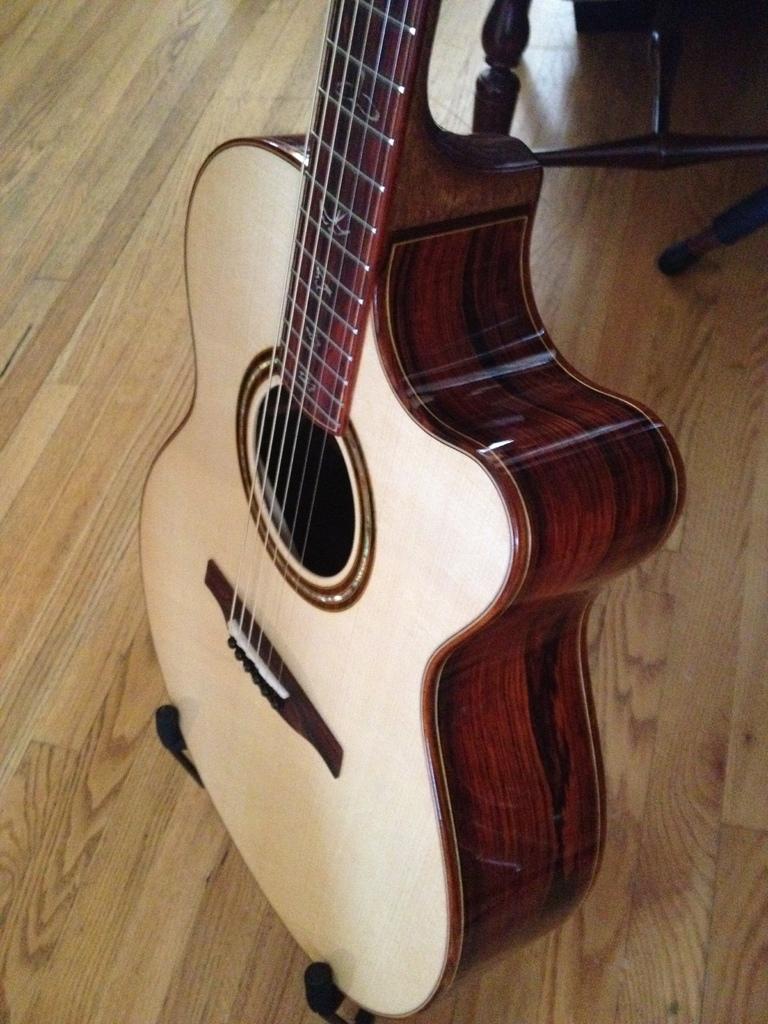Can you describe this image briefly? In this image I can see a guitar. 